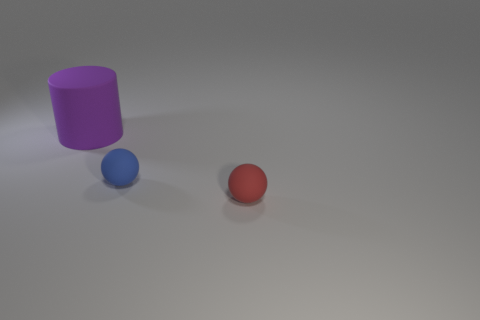Add 3 red things. How many objects exist? 6 Subtract all spheres. How many objects are left? 1 Subtract all big purple cylinders. Subtract all purple matte cylinders. How many objects are left? 1 Add 3 blue matte spheres. How many blue matte spheres are left? 4 Add 3 small red matte objects. How many small red matte objects exist? 4 Subtract 0 blue blocks. How many objects are left? 3 